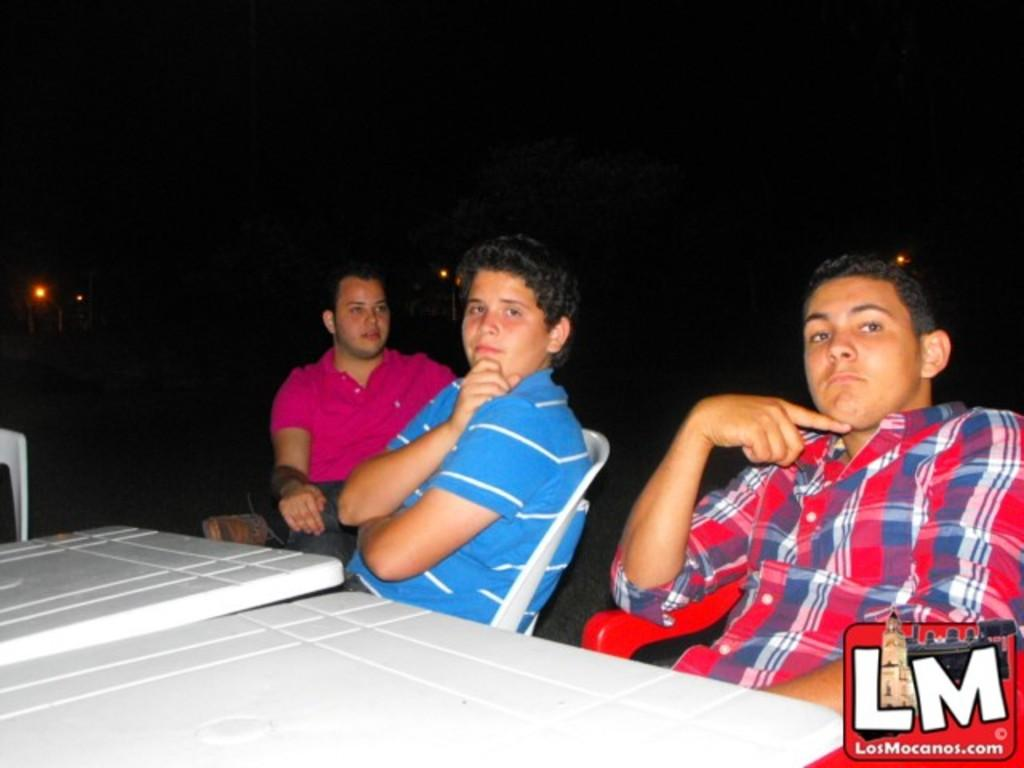How many people are in the image? There are three men in the image. What are the men doing in the image? The men are sitting on chairs. What objects are in front of the men? There are tables in front of the men. What can be seen in the background of the image? The background of the image is dark, and there are lights visible. What type of flag is being waved by the man's feet in the image? There is no flag or feet visible in the image; the men are sitting on chairs with tables in front of them. 